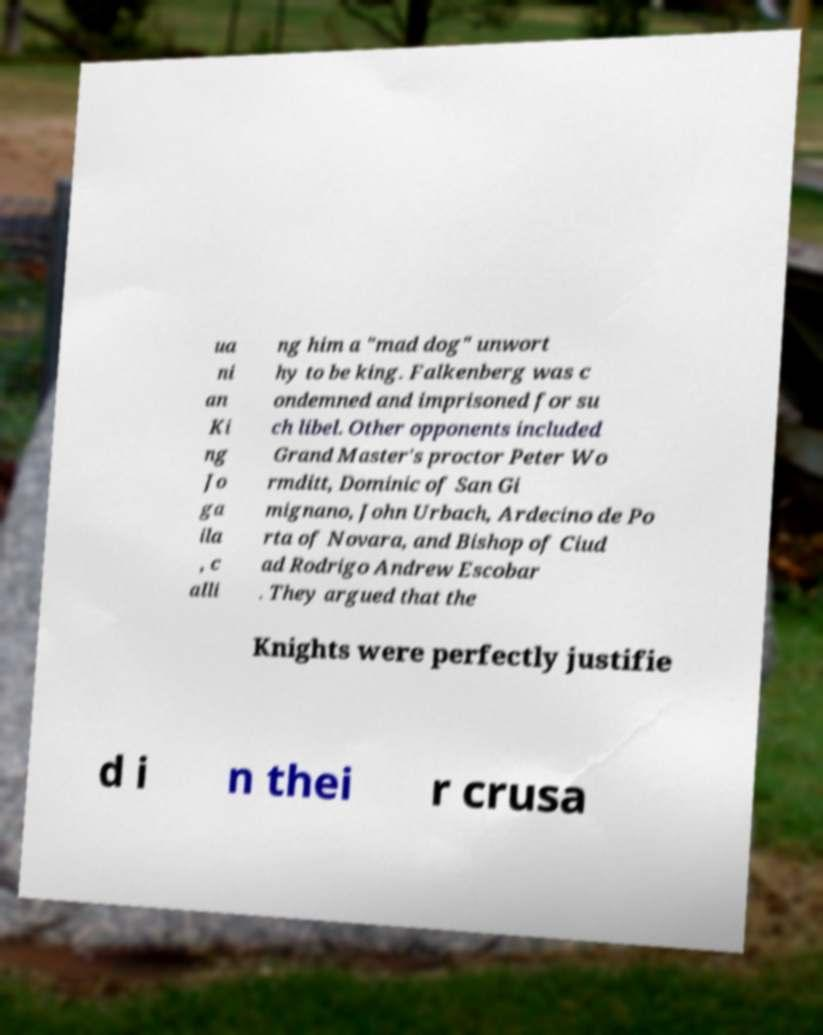There's text embedded in this image that I need extracted. Can you transcribe it verbatim? ua ni an Ki ng Jo ga ila , c alli ng him a "mad dog" unwort hy to be king. Falkenberg was c ondemned and imprisoned for su ch libel. Other opponents included Grand Master's proctor Peter Wo rmditt, Dominic of San Gi mignano, John Urbach, Ardecino de Po rta of Novara, and Bishop of Ciud ad Rodrigo Andrew Escobar . They argued that the Knights were perfectly justifie d i n thei r crusa 